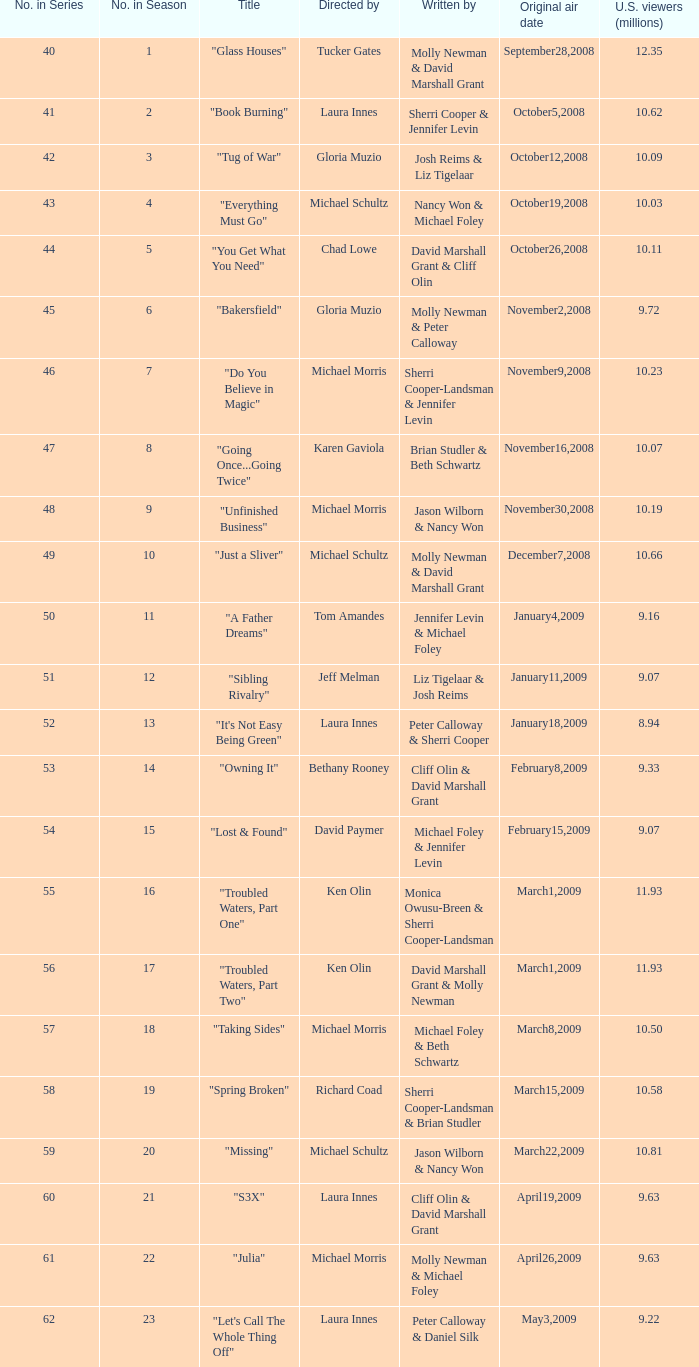Who wrote the episode whose director is Karen Gaviola? Brian Studler & Beth Schwartz. 